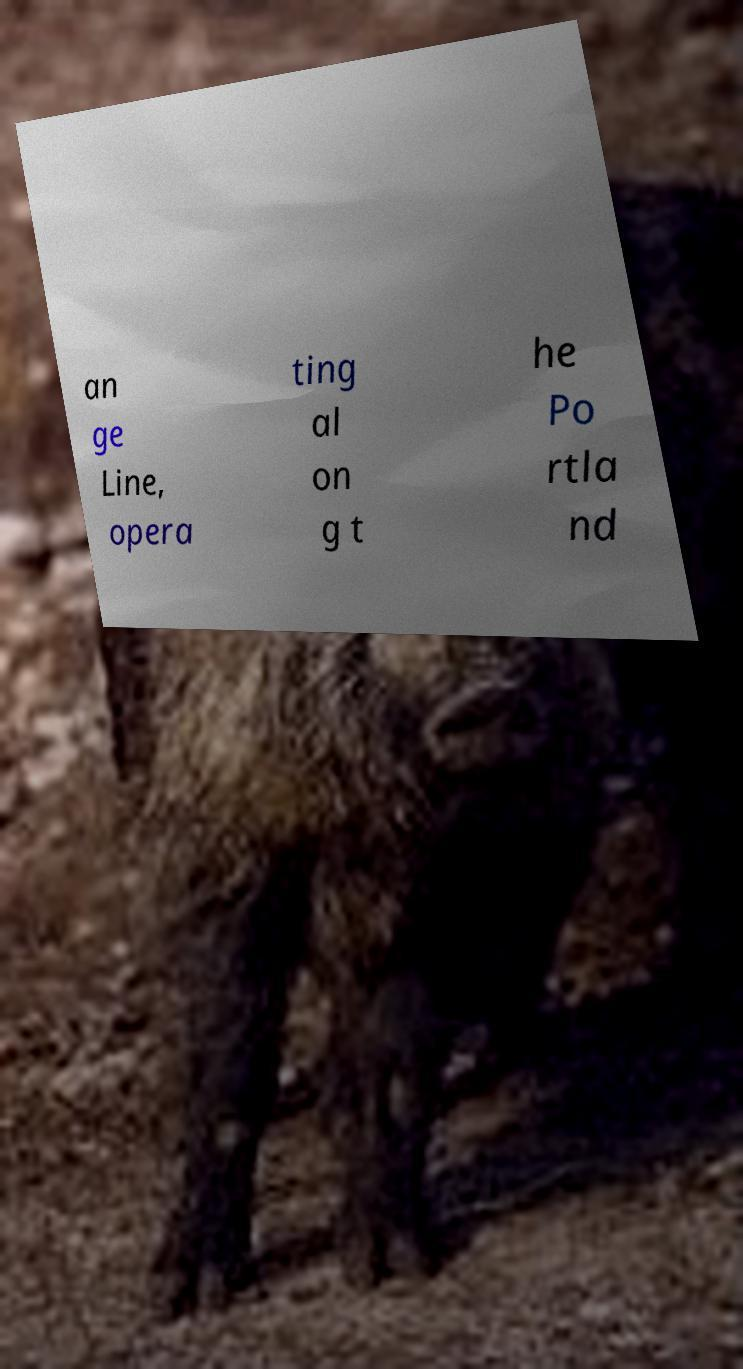Can you accurately transcribe the text from the provided image for me? an ge Line, opera ting al on g t he Po rtla nd 